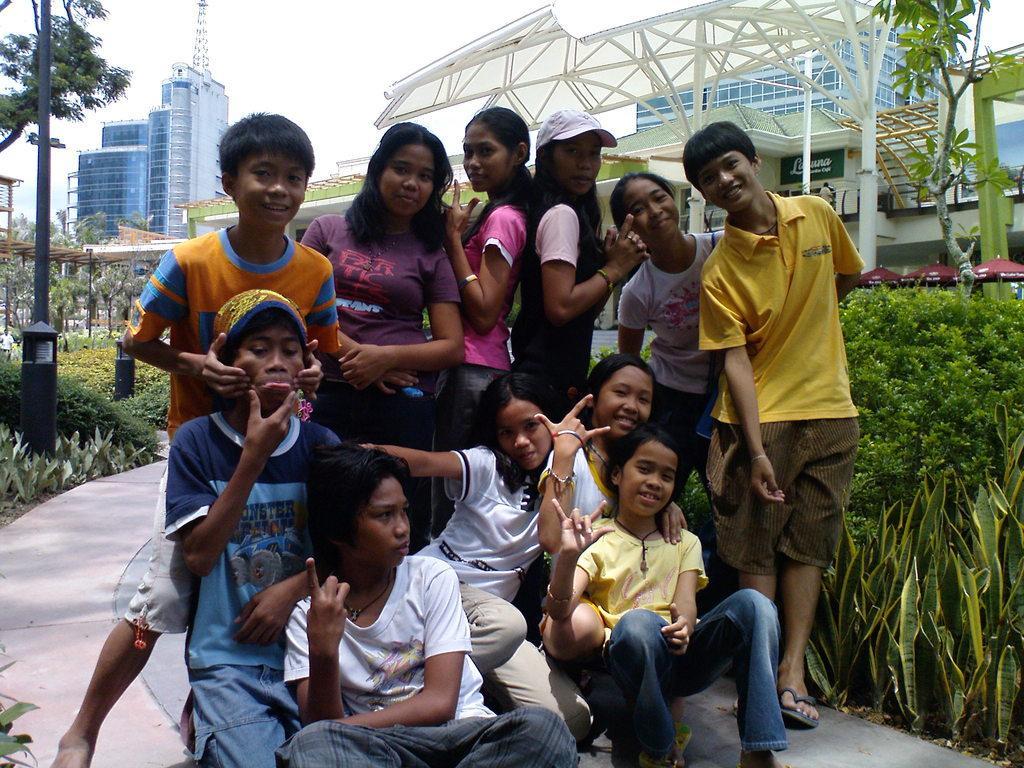How would you summarize this image in a sentence or two? In this image, we can see people posing for a photo and in the background, there are trees, buildings, shrubs. 